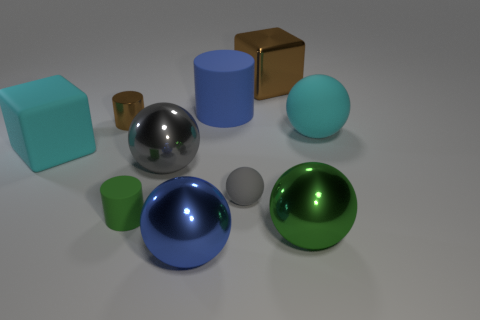Subtract all small gray rubber balls. How many balls are left? 4 Subtract all cylinders. How many objects are left? 7 Subtract 1 spheres. How many spheres are left? 4 Subtract all brown cylinders. Subtract all red blocks. How many cylinders are left? 2 Subtract all green spheres. How many brown cylinders are left? 1 Subtract all big matte blocks. Subtract all large brown cubes. How many objects are left? 8 Add 2 large cyan spheres. How many large cyan spheres are left? 3 Add 2 tiny gray spheres. How many tiny gray spheres exist? 3 Subtract all brown blocks. How many blocks are left? 1 Subtract 0 red balls. How many objects are left? 10 